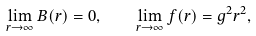<formula> <loc_0><loc_0><loc_500><loc_500>\lim _ { r \to \infty } B ( r ) = 0 , \quad \lim _ { r \to \infty } f ( r ) = g ^ { 2 } r ^ { 2 } ,</formula> 